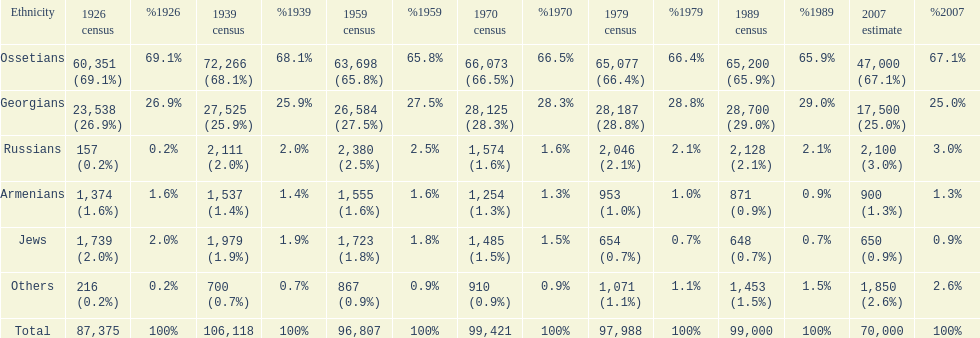What was the first census that saw a russian population of over 2,000? 1939 census. 